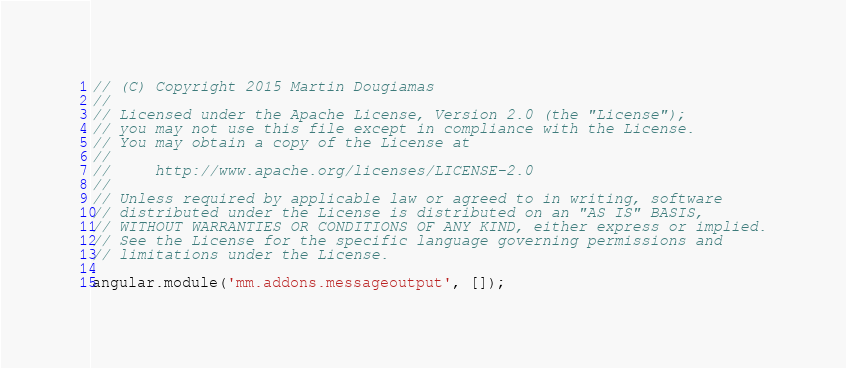<code> <loc_0><loc_0><loc_500><loc_500><_JavaScript_>// (C) Copyright 2015 Martin Dougiamas
//
// Licensed under the Apache License, Version 2.0 (the "License");
// you may not use this file except in compliance with the License.
// You may obtain a copy of the License at
//
//     http://www.apache.org/licenses/LICENSE-2.0
//
// Unless required by applicable law or agreed to in writing, software
// distributed under the License is distributed on an "AS IS" BASIS,
// WITHOUT WARRANTIES OR CONDITIONS OF ANY KIND, either express or implied.
// See the License for the specific language governing permissions and
// limitations under the License.

angular.module('mm.addons.messageoutput', []);
</code> 